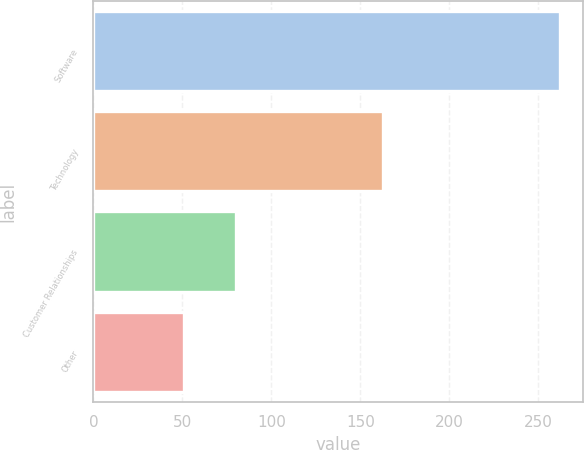Convert chart to OTSL. <chart><loc_0><loc_0><loc_500><loc_500><bar_chart><fcel>Software<fcel>Technology<fcel>Customer Relationships<fcel>Other<nl><fcel>262<fcel>163<fcel>80<fcel>51<nl></chart> 